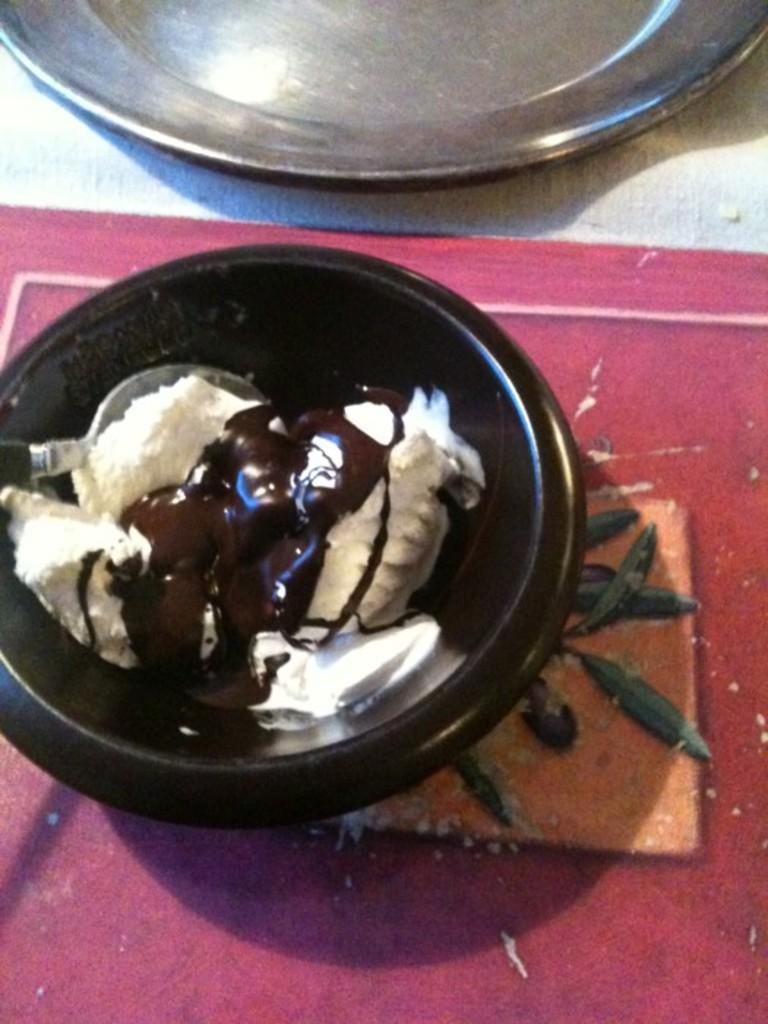What color is the bowl in the image? The bowl in the image is brown. What is the color of the floor on which the bowl is placed? The floor is red. What is inside the brown bowl? There is ice cream in the bowl. Can you describe any other objects visible in the image? There is a steel plate visible at the top of the image. What type of nerve is causing the ice cream to melt in the image? There is no indication in the image that the ice cream is melting, nor is there any mention of a nerve causing it to do so. 